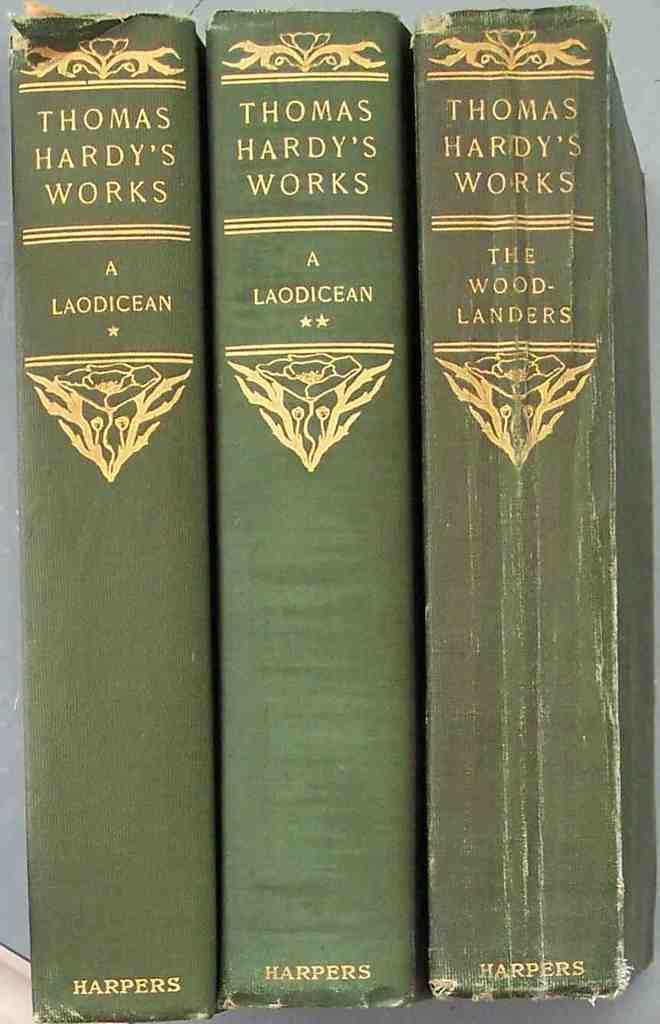Who's written work are in these books?
Offer a terse response. Thomas hardy. Who published these books?
Keep it short and to the point. Harpers. 